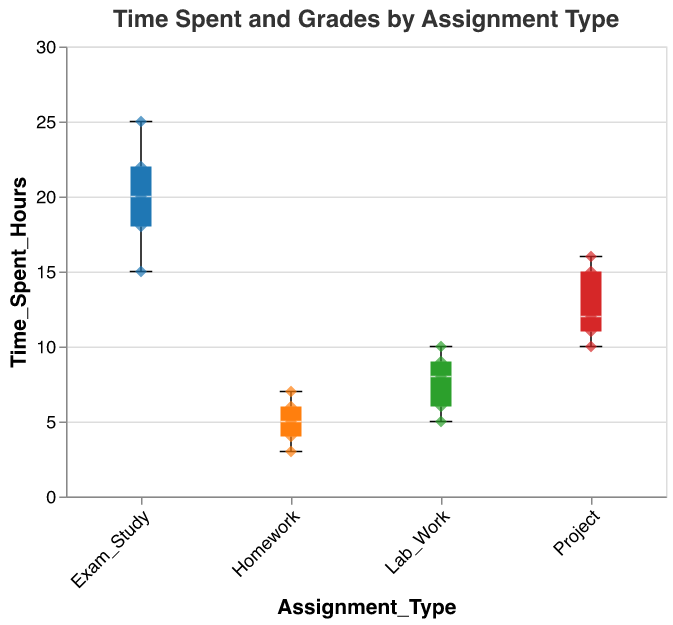How many Assignment Types are present in the plot? The x-axis shows four types: Homework, Lab_Work, Project, and Exam_Study.
Answer: 4 Which Assignment Type has the highest median time spent? By examining the vertical middle lines in each box plot, we see that "Exam_Study" has the highest median time spent.
Answer: Exam_Study What is the range of time spent on Homework? The extent of the boxplot for Homework (whiskers) stretches from 3 to 7 hours.
Answer: 3 to 7 How does the median time spent on Lab Work compare to that of Projects? The median time spent (middle line in each box) for Lab Work is around 8, while for Projects, it's around 12. Hence, Lab Work's median time is less than that of Projects.
Answer: Less What is the maximum time spent on any assignment type and which type does it belong to? The maximum value reaches 25 hours, as indicated by the whiskers of the "Exam_Study" boxplot.
Answer: 25, Exam_Study How many scatter points are in the "Project" category? By counting the points within the "Project" box plot on the x-axis, there are 5.
Answer: 5 Which Assignment Type shows the most variation in time spent? The range can be observed from the length of the whiskers in each box plot. "Exam_Study" ranges from 15 to 25 hours, depicting the highest variation.
Answer: Exam_Study Between Homework and Lab Work, which category has data points indicating higher grades for similar time spent? "Lab_Work" has data points (scatter points) with higher grades in comparison to "Homework" for similar time ranges of 5 to 10 hours.
Answer: Lab Work What is the shape used for scatter points, and why might this shape be chosen? The scatter points are in the shape of diamonds, which provide visual distinction and clarity alongside box plots.
Answer: Diamond What can be inferred about the relationship between time spent and grades received in the Exam Study category? In the "Exam_Study" category, higher time spent generally correlates with grades clustering between 88 and 94, indicating higher consistency in achieving good grades through sustained study time.
Answer: Consistent good grades 